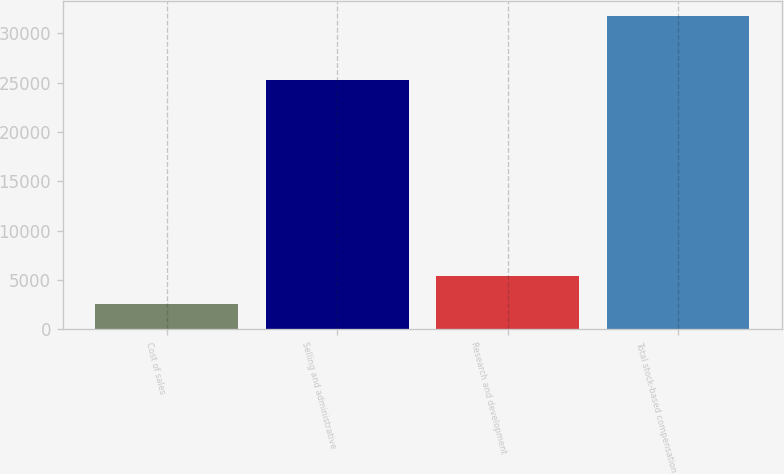Convert chart to OTSL. <chart><loc_0><loc_0><loc_500><loc_500><bar_chart><fcel>Cost of sales<fcel>Selling and administrative<fcel>Research and development<fcel>Total stock-based compensation<nl><fcel>2523<fcel>25252<fcel>5441.5<fcel>31708<nl></chart> 